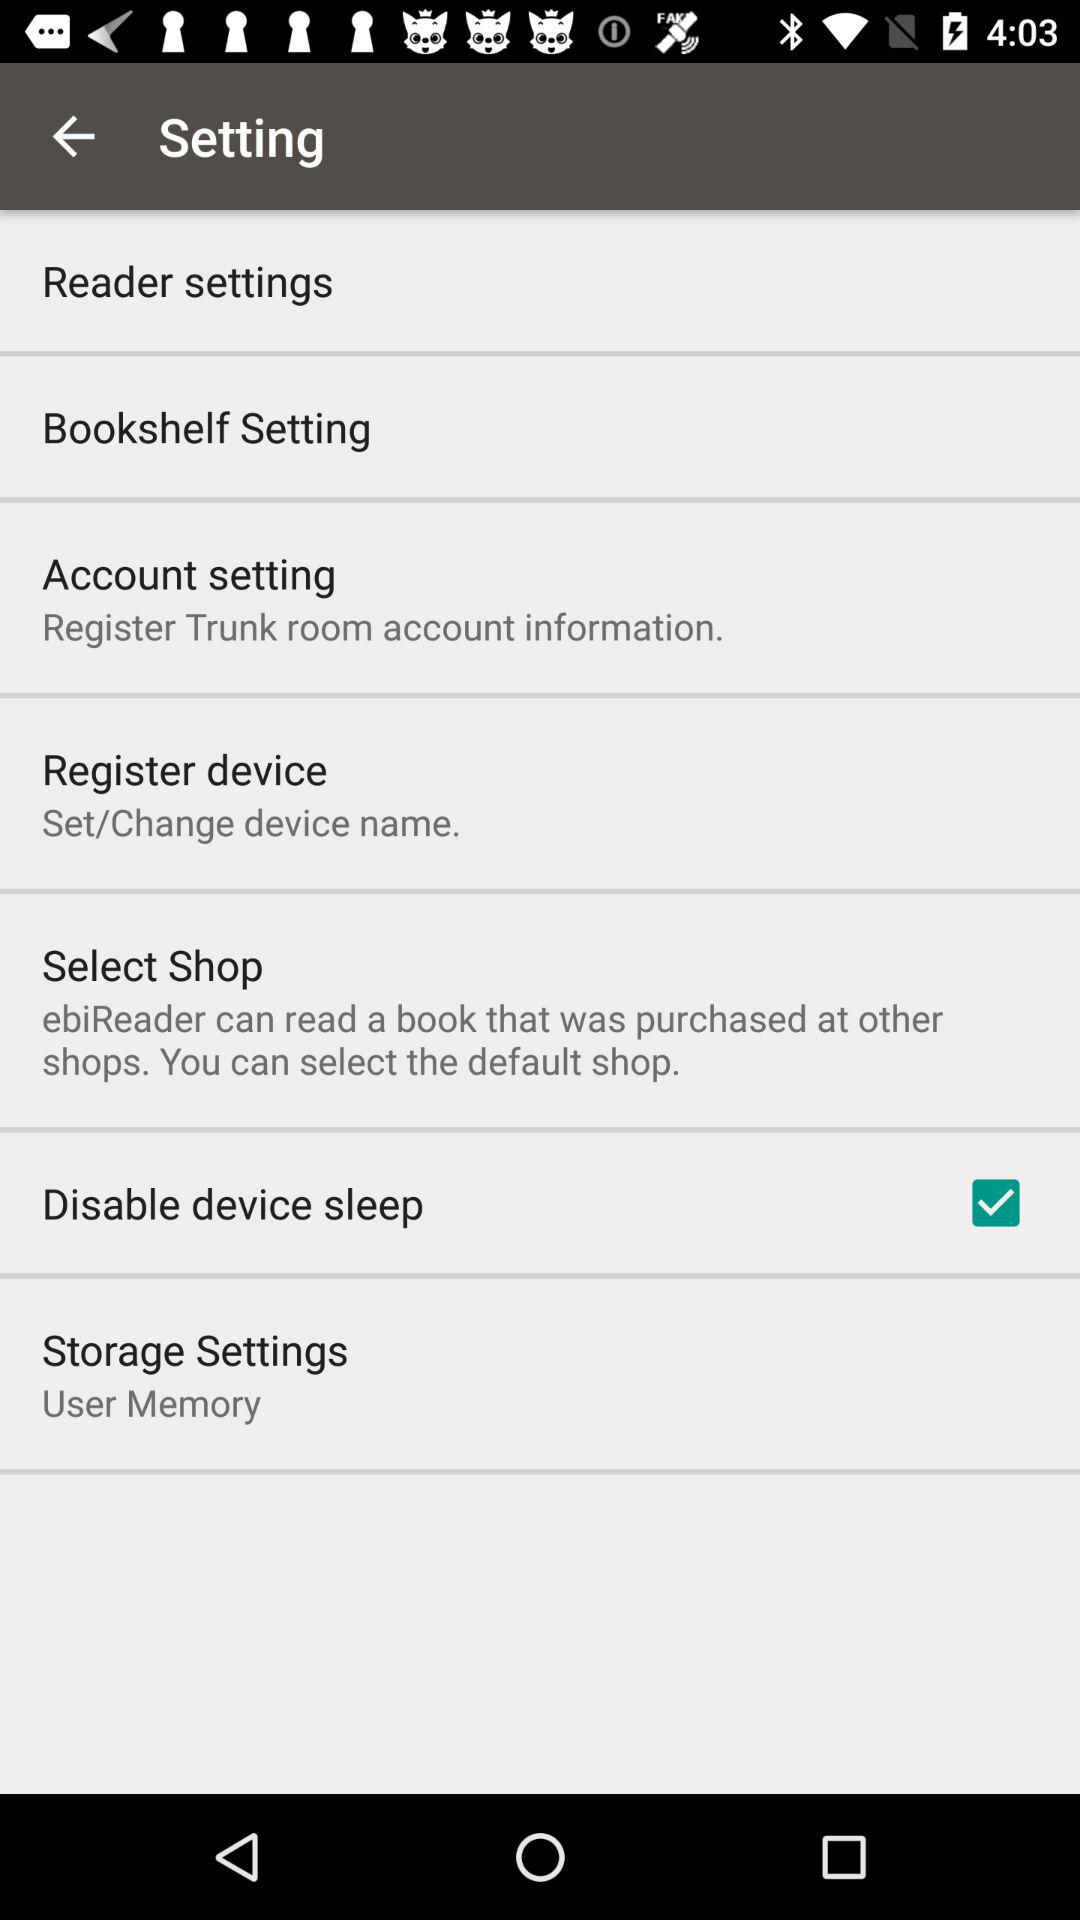What is the name of the application that can read a book bought from another shop? The name of the application that can read a book bought from another shop is "ebiReader". 